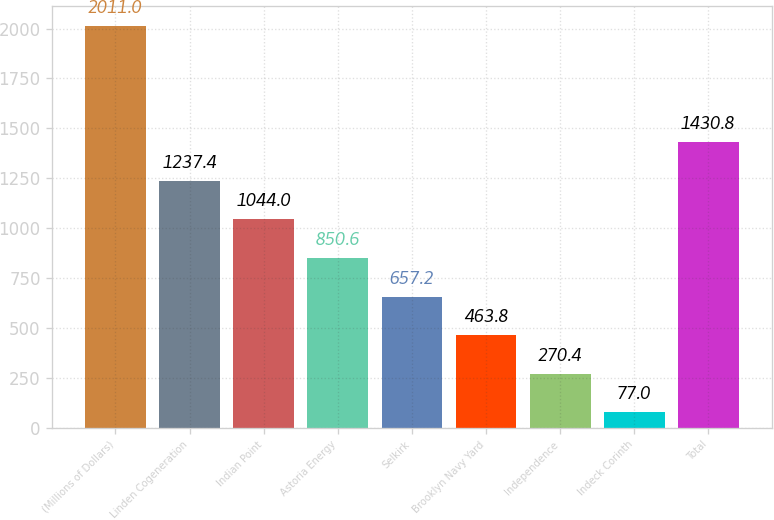<chart> <loc_0><loc_0><loc_500><loc_500><bar_chart><fcel>(Millions of Dollars)<fcel>Linden Cogeneration<fcel>Indian Point<fcel>Astoria Energy<fcel>Selkirk<fcel>Brooklyn Navy Yard<fcel>Independence<fcel>Indeck Corinth<fcel>Total<nl><fcel>2011<fcel>1237.4<fcel>1044<fcel>850.6<fcel>657.2<fcel>463.8<fcel>270.4<fcel>77<fcel>1430.8<nl></chart> 